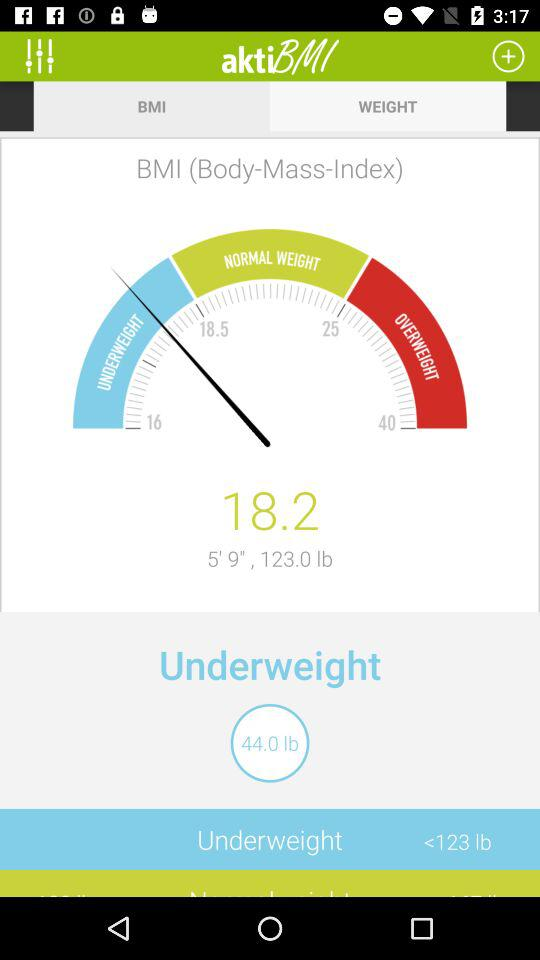What is the underweight parameter in lb? The underweight parameter is less than 123 lbs. 